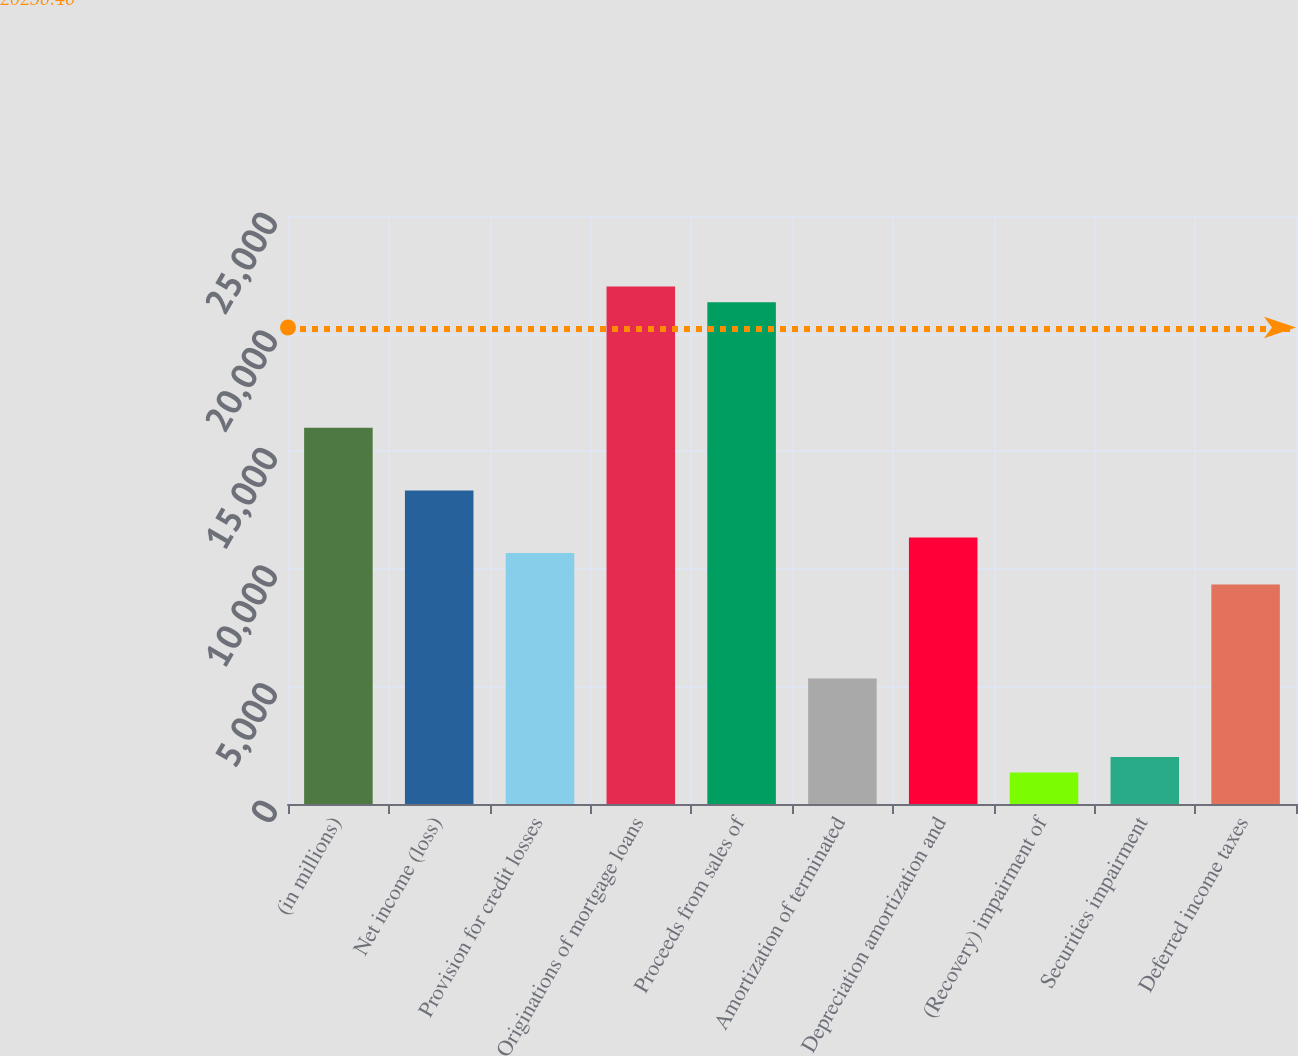Convert chart to OTSL. <chart><loc_0><loc_0><loc_500><loc_500><bar_chart><fcel>(in millions)<fcel>Net income (loss)<fcel>Provision for credit losses<fcel>Originations of mortgage loans<fcel>Proceeds from sales of<fcel>Amortization of terminated<fcel>Depreciation amortization and<fcel>(Recovery) impairment of<fcel>Securities impairment<fcel>Deferred income taxes<nl><fcel>15999.4<fcel>13333<fcel>10666.6<fcel>21998.8<fcel>21332.2<fcel>5333.8<fcel>11333.2<fcel>1334.2<fcel>2000.8<fcel>9333.4<nl></chart> 